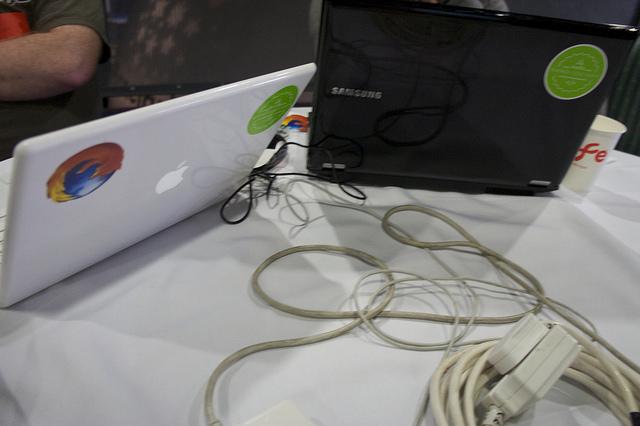What color are the stickers?
Keep it brief. Green. How many computers are there?
Write a very short answer. 2. What logo is on the white laptop?
Short answer required. Apple. 